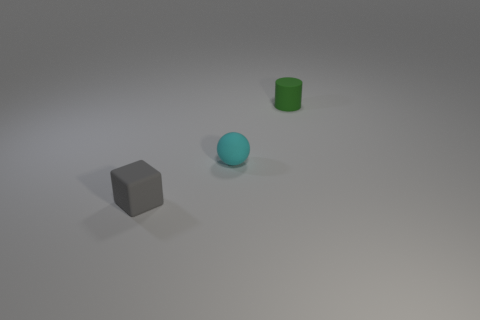How many shiny things are tiny gray objects or big blue blocks?
Provide a short and direct response. 0. What number of objects are gray blocks or cyan spheres on the left side of the small green matte object?
Your answer should be very brief. 2. How many other things are the same color as the small cylinder?
Your answer should be very brief. 0. What number of other things are made of the same material as the small cyan sphere?
Your response must be concise. 2. Are there the same number of tiny matte cubes that are left of the gray object and small green rubber cylinders that are on the left side of the tiny cyan matte thing?
Keep it short and to the point. Yes. The object that is behind the sphere has what shape?
Make the answer very short. Cylinder. There is a tiny gray object that is made of the same material as the small cyan object; what is its shape?
Your answer should be compact. Cube. Are there any other things that are the same shape as the tiny green rubber thing?
Keep it short and to the point. No. What number of small blocks are behind the small cylinder?
Offer a terse response. 0. Is the number of tiny cyan things behind the green matte cylinder the same as the number of tiny metal objects?
Offer a terse response. Yes. 